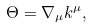Convert formula to latex. <formula><loc_0><loc_0><loc_500><loc_500>\Theta = \nabla _ { \mu } k ^ { \mu } ,</formula> 